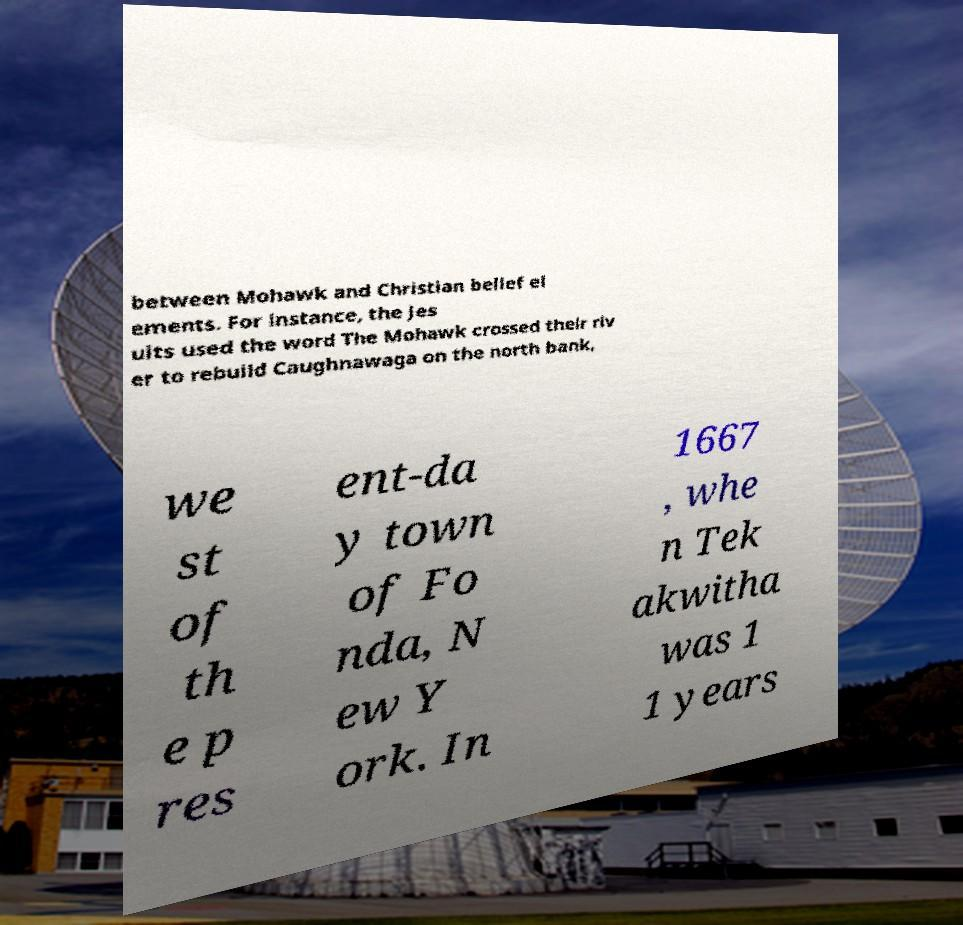Could you extract and type out the text from this image? between Mohawk and Christian belief el ements. For instance, the Jes uits used the word The Mohawk crossed their riv er to rebuild Caughnawaga on the north bank, we st of th e p res ent-da y town of Fo nda, N ew Y ork. In 1667 , whe n Tek akwitha was 1 1 years 